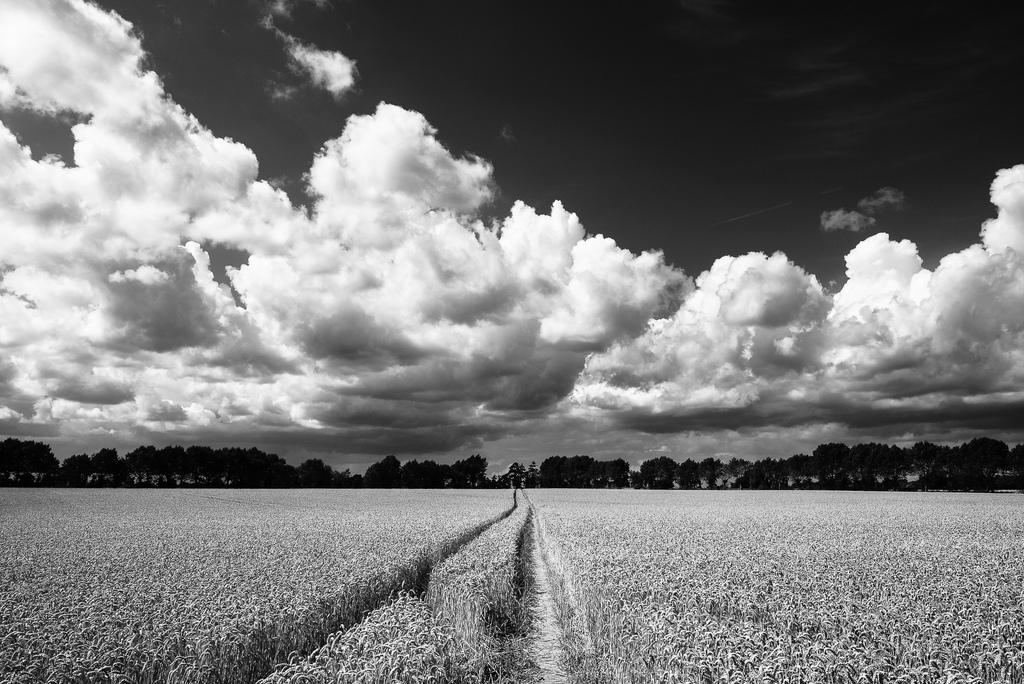What is the main setting of the image? There is a field in the image. What can be seen in the background of the field? There are trees in the background of the image. What part of the natural environment is visible in the image? The sky is visible in the image. How would you describe the weather based on the appearance of the sky? The sky appears to be cloudy in the image. How many feet are visible in the image? There are no feet visible in the image; it features a field, trees, and a cloudy sky. 